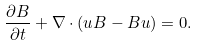<formula> <loc_0><loc_0><loc_500><loc_500>\frac { \partial { B } } { \partial t } + { \nabla } \cdot ( { u B } - { B u } ) = 0 .</formula> 